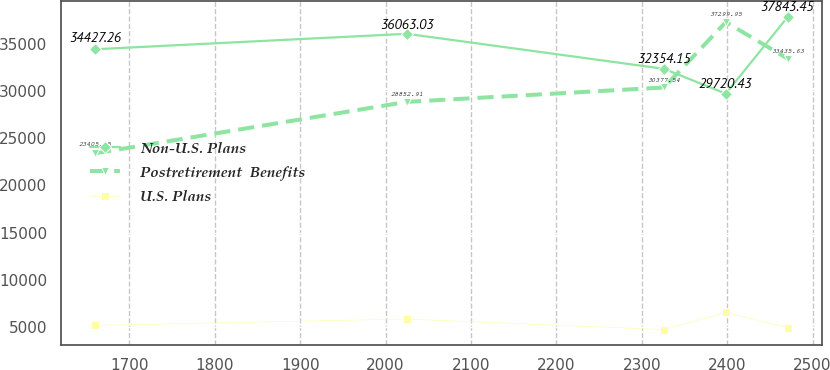Convert chart to OTSL. <chart><loc_0><loc_0><loc_500><loc_500><line_chart><ecel><fcel>Non-U.S. Plans<fcel>Postretirement  Benefits<fcel>U.S. Plans<nl><fcel>1659.82<fcel>34427.3<fcel>23405.7<fcel>5174.02<nl><fcel>2024.89<fcel>36063<fcel>28852.9<fcel>5851.6<nl><fcel>2325.95<fcel>32354.2<fcel>30377.5<fcel>4729.23<nl><fcel>2398.38<fcel>29720.4<fcel>37299.9<fcel>6545.18<nl><fcel>2470.81<fcel>37843.4<fcel>33435.6<fcel>4936.86<nl></chart> 